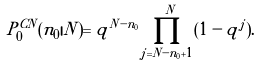<formula> <loc_0><loc_0><loc_500><loc_500>P _ { 0 } ^ { C N } ( n _ { 0 } | N ) = q ^ { N - n _ { 0 } } \prod _ { j = N - n _ { 0 } + 1 } ^ { N } ( 1 - q ^ { j } ) .</formula> 